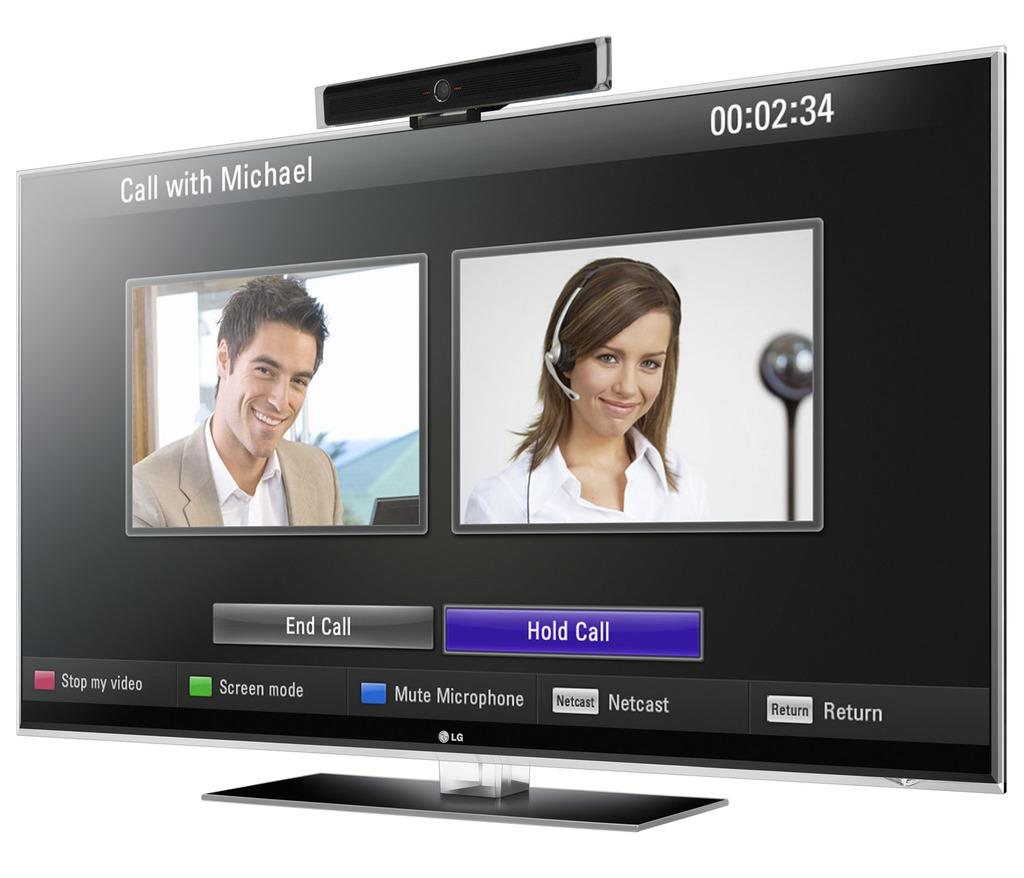<image>
Create a compact narrative representing the image presented. A large TV screen shows a call with Michael. 